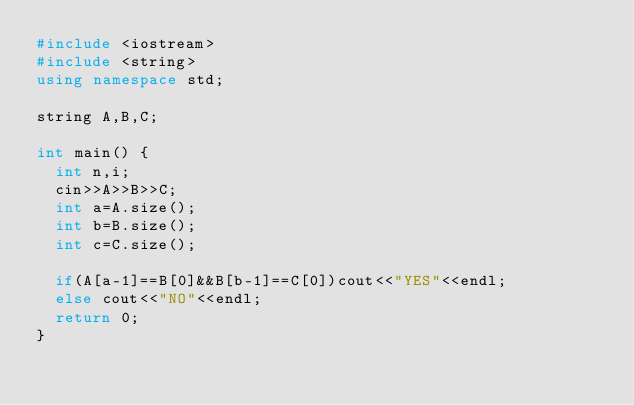Convert code to text. <code><loc_0><loc_0><loc_500><loc_500><_C++_>#include <iostream>
#include <string>
using namespace std;

string A,B,C;

int main() {
	int n,i;
	cin>>A>>B>>C;
	int a=A.size(); 
	int b=B.size();
	int c=C.size();
	
	if(A[a-1]==B[0]&&B[b-1]==C[0])cout<<"YES"<<endl;
	else cout<<"NO"<<endl;
	return 0;
}</code> 